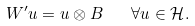<formula> <loc_0><loc_0><loc_500><loc_500>W ^ { \prime } u = u \otimes B \quad \forall u \in \mathcal { H } .</formula> 